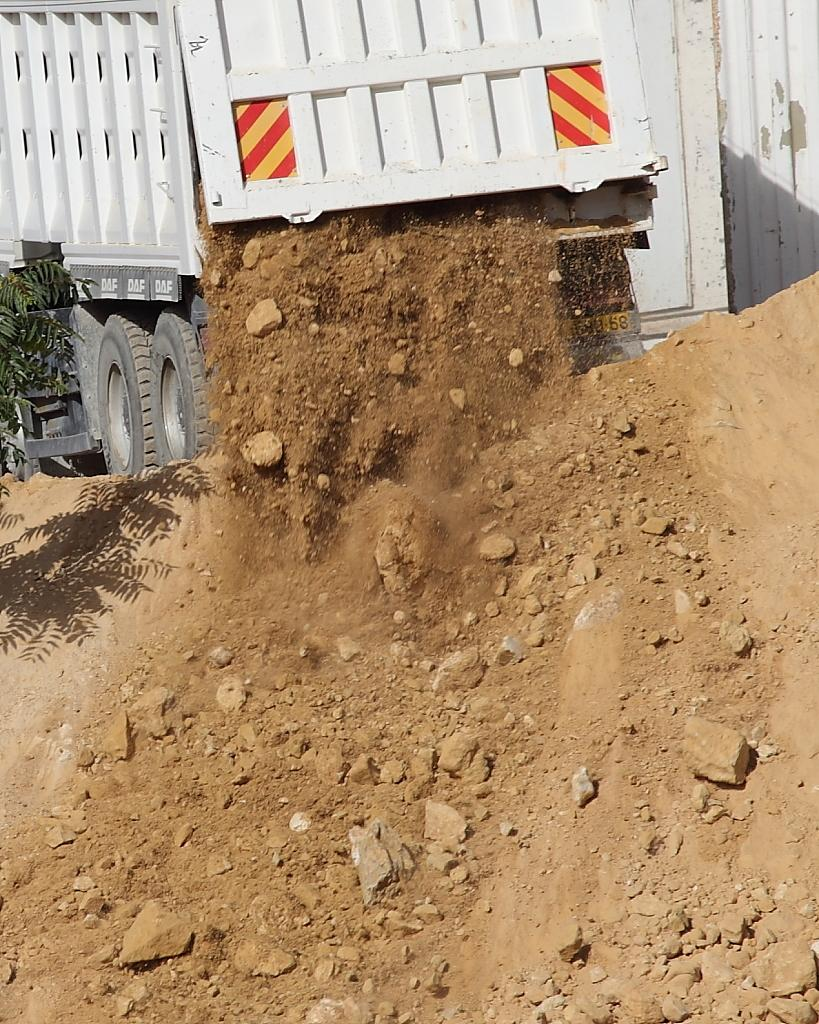What is the main subject in the image? There is a vehicle in the image. What type of surface is visible at the bottom of the image? There is soil visible at the bottom of the image. What can be seen on the left side of the image? There is a plant on the left side of the image. What date is marked on the calendar in the image? There is no calendar present in the image. Can you describe the boy's outfit in the image? There is no boy present in the image. What type of transportation system is visible in the image? There is no railway or any other transportation system visible in the image. 